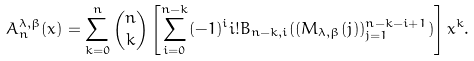Convert formula to latex. <formula><loc_0><loc_0><loc_500><loc_500>A _ { n } ^ { \lambda , \beta } ( x ) = \sum _ { k = 0 } ^ { n } \binom { n } { k } \left [ \sum _ { i = 0 } ^ { n - k } ( - 1 ) ^ { i } i ! B _ { n - k , i } ( ( M _ { \lambda , \beta } ( j ) ) _ { j = 1 } ^ { n - k - i + 1 } ) \right ] x ^ { k } .</formula> 